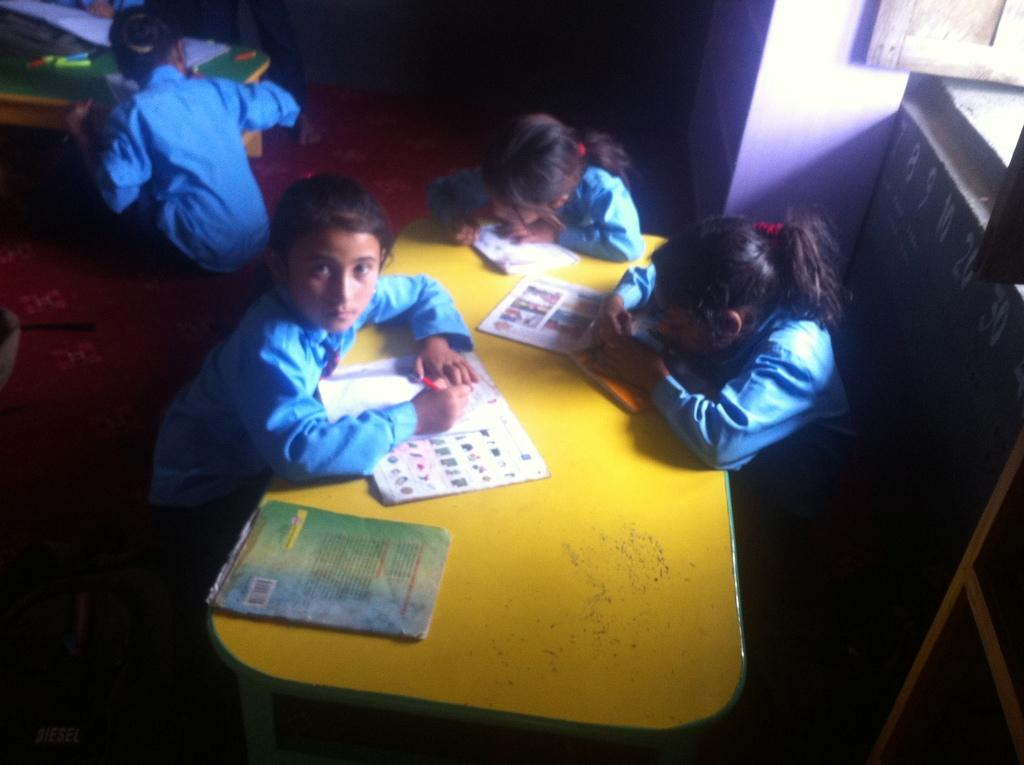How many children are present in the image? There are three children in the image. What are the children doing in the image? The children are sitting around a table and writing in their books. What color are the children's dresses in the image? The children are wearing blue color dresses. What type of creature can be seen interacting with the children in the image? There is no creature present in the image; the children are sitting around a table and writing in their books. What nation are the children from in the image? The provided facts do not mention the children's nationality, so it cannot be determined from the image. 